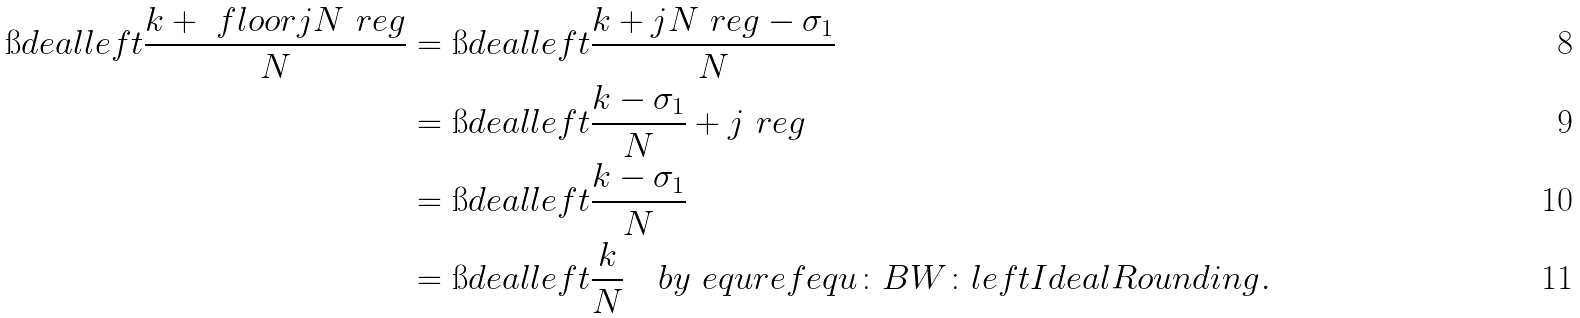<formula> <loc_0><loc_0><loc_500><loc_500>\i d e a l l e f t { \frac { k + \ f l o o r { j N \ r e g } } { N } } & = \i d e a l l e f t { \frac { k + j N \ r e g - \sigma _ { 1 } } { N } } \\ & = \i d e a l l e f t { \frac { k - \sigma _ { 1 } } { N } + j \ r e g } \\ & = \i d e a l l e f t { \frac { k - \sigma _ { 1 } } { N } } \\ & = \i d e a l l e f t { \frac { k } { N } } \quad b y \ e q u r e f { e q u \colon B W \colon l e f t I d e a l R o u n d i n g } .</formula> 